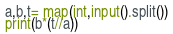<code> <loc_0><loc_0><loc_500><loc_500><_Python_>a,b,t= map(int,input().split())
print(b*(t//a))</code> 